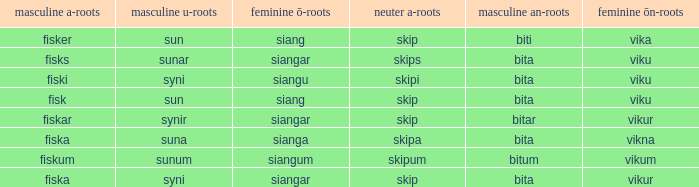What is the an-stem for the word which has an ö-stems of siangar and an u-stem ending of syni? Bita. 